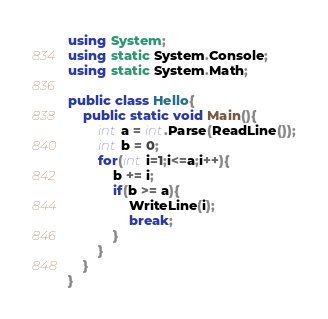Convert code to text. <code><loc_0><loc_0><loc_500><loc_500><_C#_>using System;
using static System.Console;
using static System.Math;

public class Hello{
    public static void Main(){
        int a = int.Parse(ReadLine());
        int b = 0;
        for(int i=1;i<=a;i++){
            b += i;
            if(b >= a){
                WriteLine(i);
                break;
            }
        }
    }
}
</code> 